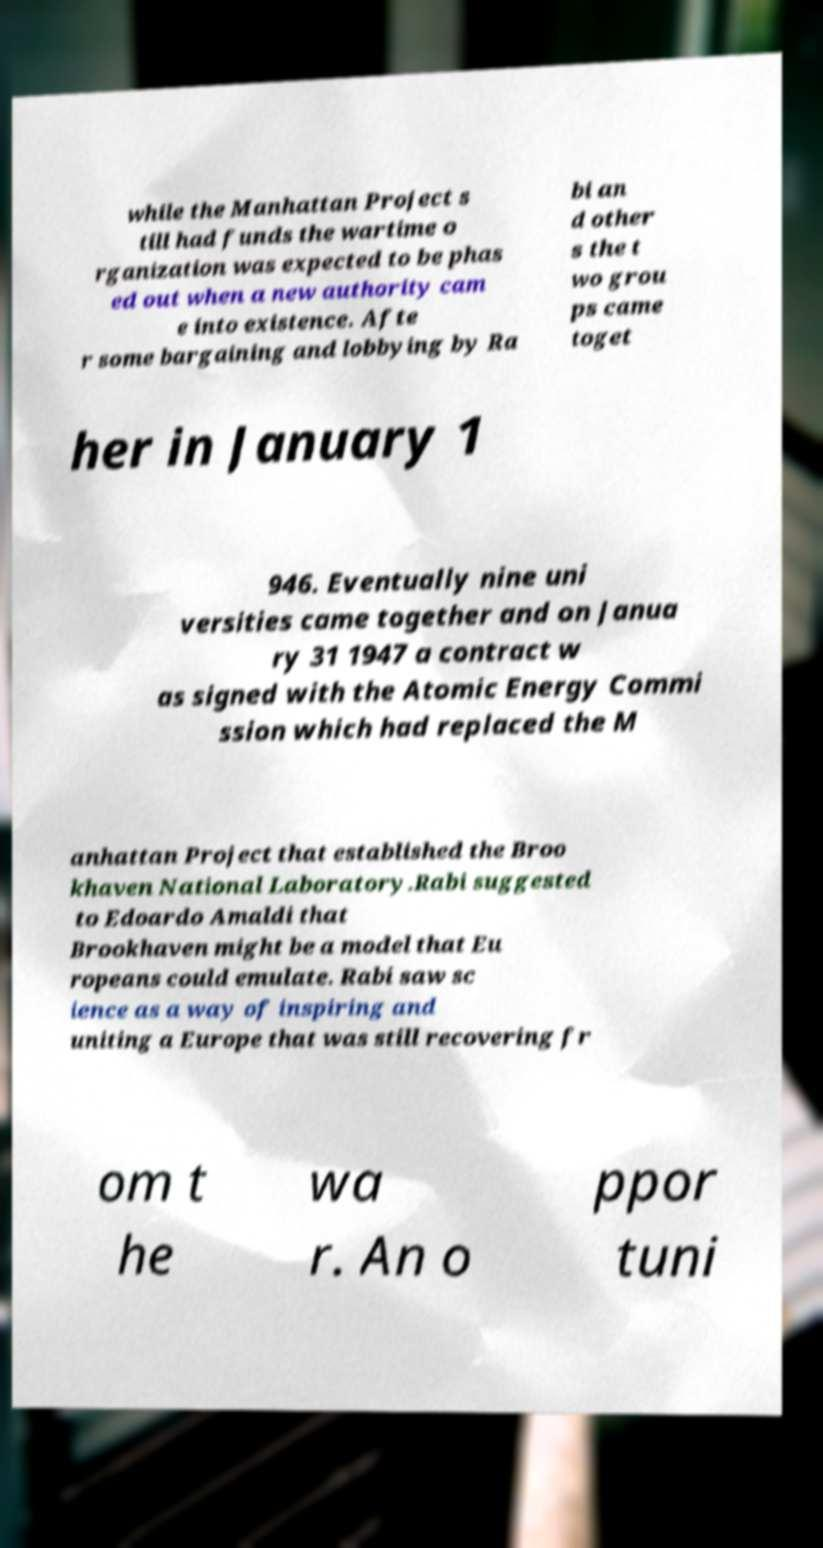I need the written content from this picture converted into text. Can you do that? while the Manhattan Project s till had funds the wartime o rganization was expected to be phas ed out when a new authority cam e into existence. Afte r some bargaining and lobbying by Ra bi an d other s the t wo grou ps came toget her in January 1 946. Eventually nine uni versities came together and on Janua ry 31 1947 a contract w as signed with the Atomic Energy Commi ssion which had replaced the M anhattan Project that established the Broo khaven National Laboratory.Rabi suggested to Edoardo Amaldi that Brookhaven might be a model that Eu ropeans could emulate. Rabi saw sc ience as a way of inspiring and uniting a Europe that was still recovering fr om t he wa r. An o ppor tuni 